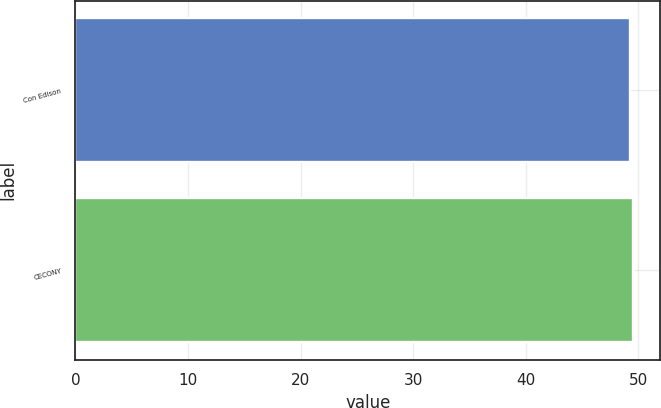Convert chart. <chart><loc_0><loc_0><loc_500><loc_500><bar_chart><fcel>Con Edison<fcel>CECONY<nl><fcel>49.3<fcel>49.5<nl></chart> 